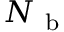<formula> <loc_0><loc_0><loc_500><loc_500>N _ { b }</formula> 